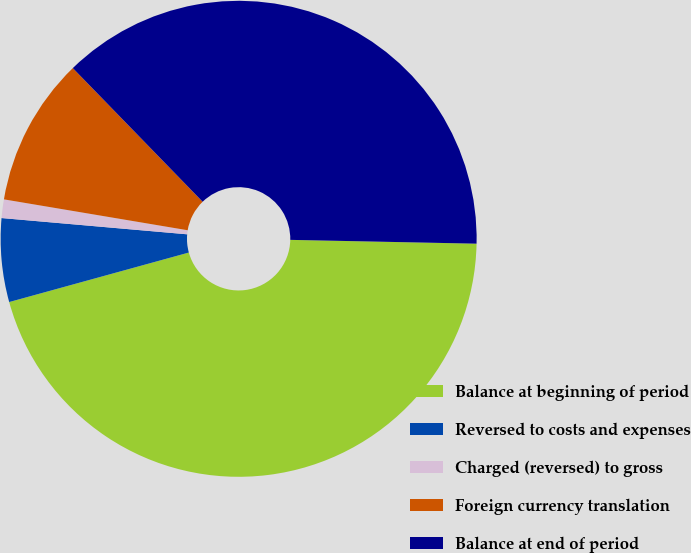Convert chart. <chart><loc_0><loc_0><loc_500><loc_500><pie_chart><fcel>Balance at beginning of period<fcel>Reversed to costs and expenses<fcel>Charged (reversed) to gross<fcel>Foreign currency translation<fcel>Balance at end of period<nl><fcel>45.39%<fcel>5.67%<fcel>1.26%<fcel>10.08%<fcel>37.59%<nl></chart> 